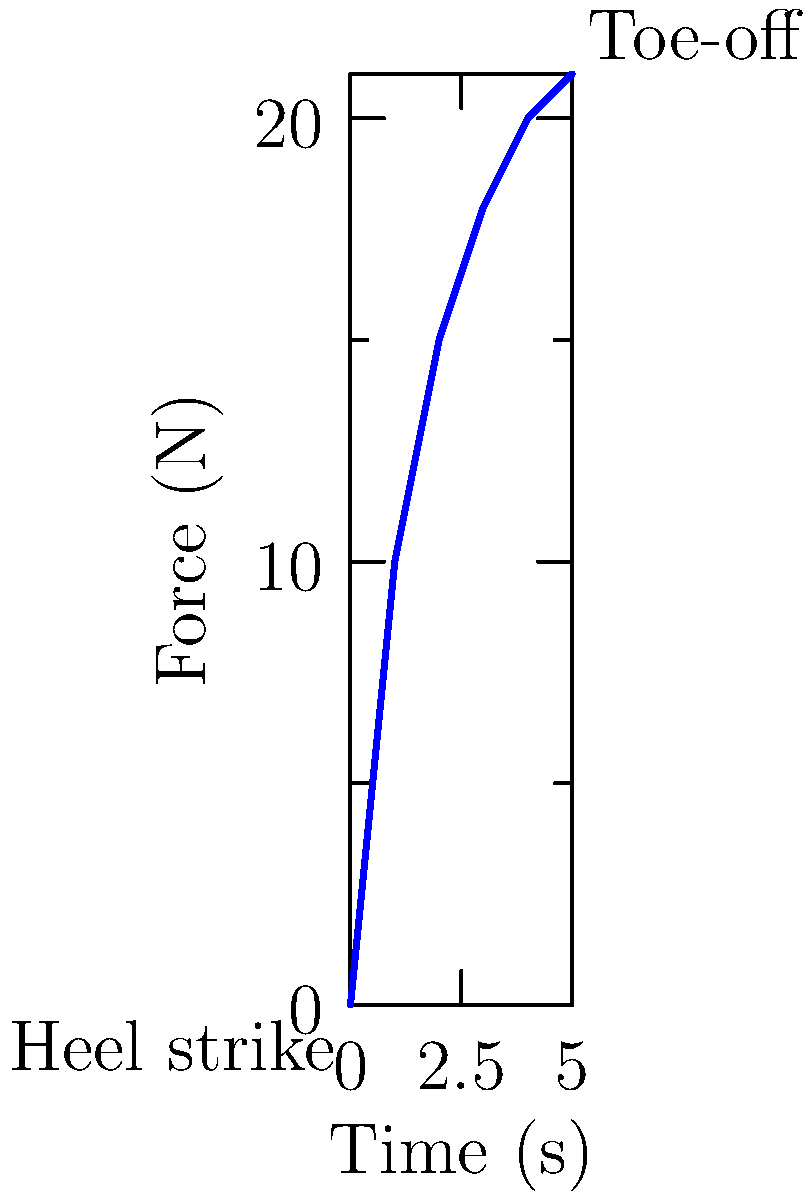The graph shows the distribution of force on a prosthetic foot during a single step. Given that the prosthetic weighs 1.5 kg and the person using it weighs 70 kg, calculate the maximum force exerted on the prosthetic as a percentage of the user's body weight. To solve this problem, we'll follow these steps:

1. Determine the maximum force from the graph:
   The maximum force shown is 21 N at the toe-off phase.

2. Calculate the user's weight in Newtons:
   Weight = mass × acceleration due to gravity
   $W = 70 \text{ kg} \times 9.8 \text{ m/s}^2 = 686 \text{ N}$

3. Calculate the prosthetic's weight in Newtons:
   $W_p = 1.5 \text{ kg} \times 9.8 \text{ m/s}^2 = 14.7 \text{ N}$

4. Calculate the total force on the prosthetic:
   Total force = Maximum force from graph + Prosthetic weight
   $F_t = 21 \text{ N} + 14.7 \text{ N} = 35.7 \text{ N}$

5. Calculate the percentage of the user's body weight:
   Percentage = (Total force / User's weight) × 100%
   $\text{Percentage} = \frac{35.7 \text{ N}}{686 \text{ N}} \times 100\% = 5.20\%$
Answer: 5.20% 